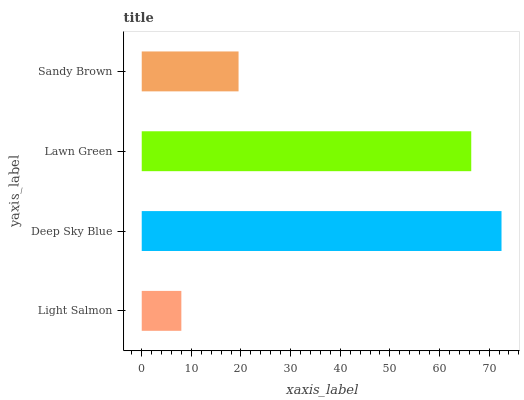Is Light Salmon the minimum?
Answer yes or no. Yes. Is Deep Sky Blue the maximum?
Answer yes or no. Yes. Is Lawn Green the minimum?
Answer yes or no. No. Is Lawn Green the maximum?
Answer yes or no. No. Is Deep Sky Blue greater than Lawn Green?
Answer yes or no. Yes. Is Lawn Green less than Deep Sky Blue?
Answer yes or no. Yes. Is Lawn Green greater than Deep Sky Blue?
Answer yes or no. No. Is Deep Sky Blue less than Lawn Green?
Answer yes or no. No. Is Lawn Green the high median?
Answer yes or no. Yes. Is Sandy Brown the low median?
Answer yes or no. Yes. Is Light Salmon the high median?
Answer yes or no. No. Is Light Salmon the low median?
Answer yes or no. No. 